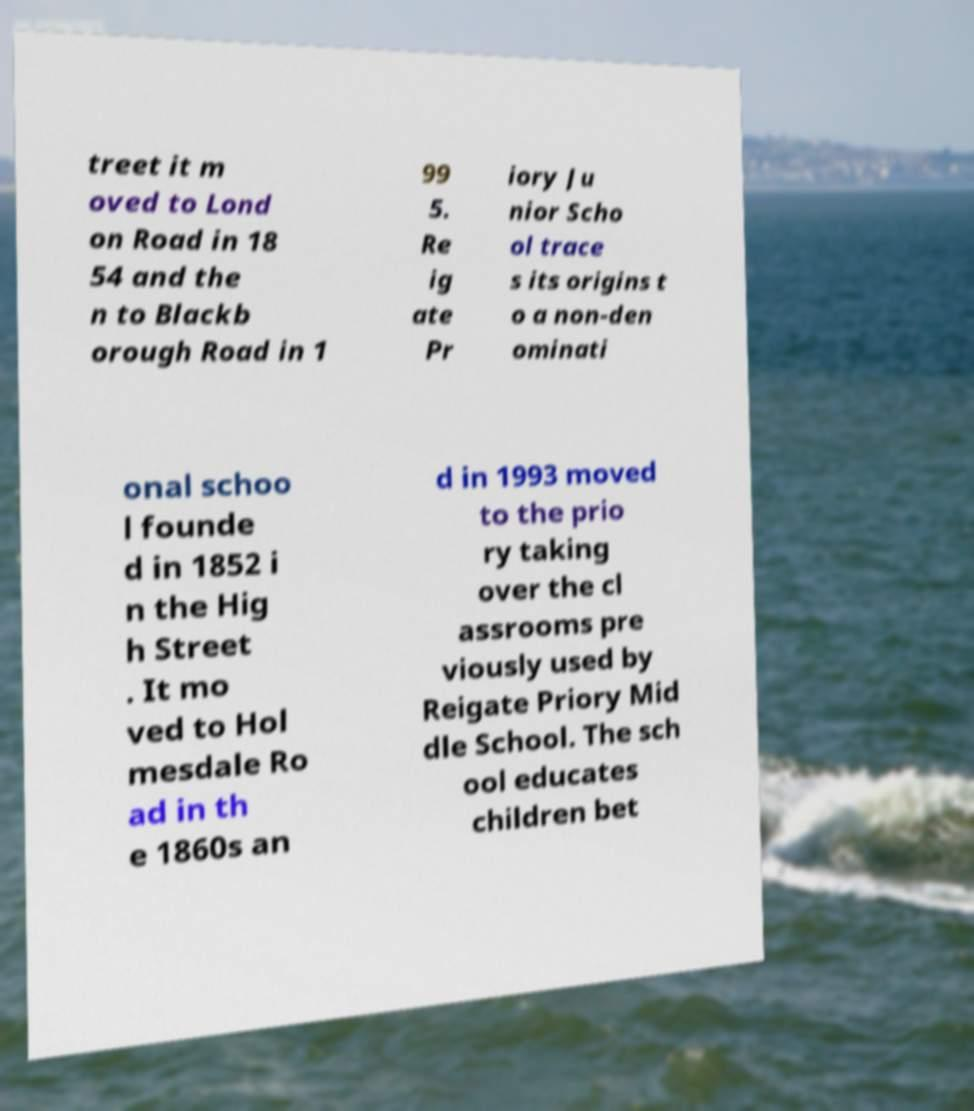Please identify and transcribe the text found in this image. treet it m oved to Lond on Road in 18 54 and the n to Blackb orough Road in 1 99 5. Re ig ate Pr iory Ju nior Scho ol trace s its origins t o a non-den ominati onal schoo l founde d in 1852 i n the Hig h Street . It mo ved to Hol mesdale Ro ad in th e 1860s an d in 1993 moved to the prio ry taking over the cl assrooms pre viously used by Reigate Priory Mid dle School. The sch ool educates children bet 